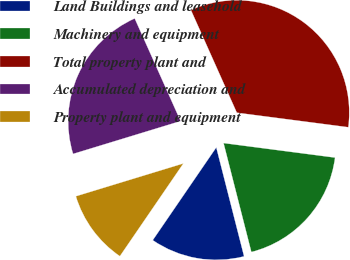Convert chart. <chart><loc_0><loc_0><loc_500><loc_500><pie_chart><fcel>Land Buildings and leasehold<fcel>Machinery and equipment<fcel>Total property plant and<fcel>Accumulated depreciation and<fcel>Property plant and equipment<nl><fcel>13.53%<fcel>18.96%<fcel>33.75%<fcel>23.02%<fcel>10.73%<nl></chart> 